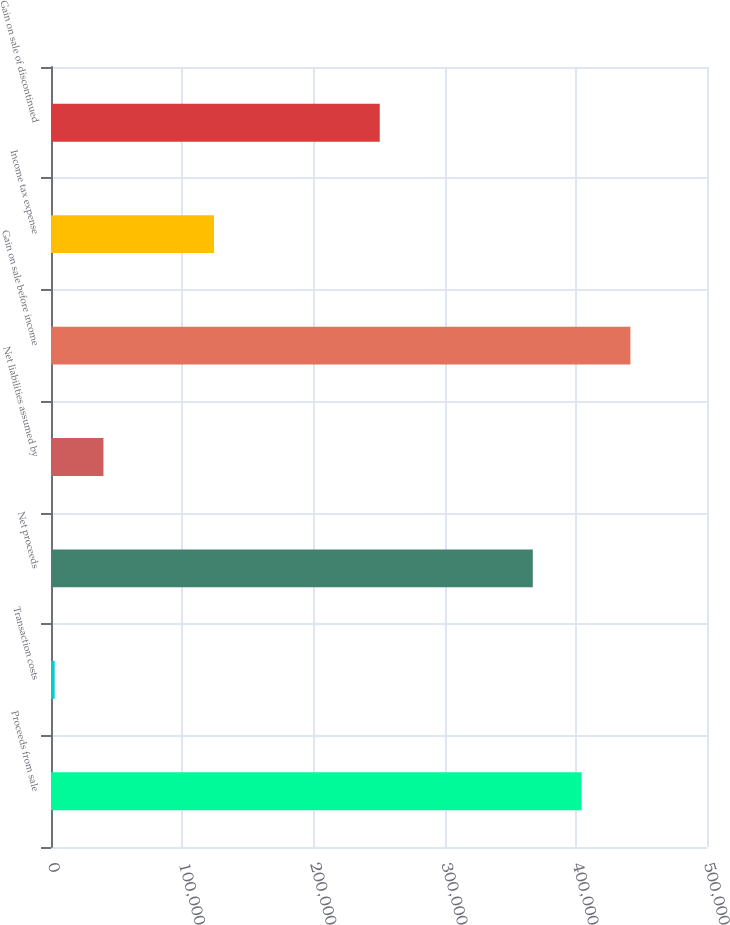<chart> <loc_0><loc_0><loc_500><loc_500><bar_chart><fcel>Proceeds from sale<fcel>Transaction costs<fcel>Net proceeds<fcel>Net liabilities assumed by<fcel>Gain on sale before income<fcel>Income tax expense<fcel>Gain on sale of discontinued<nl><fcel>404426<fcel>2778<fcel>367222<fcel>39982.4<fcel>441631<fcel>124249<fcel>250573<nl></chart> 